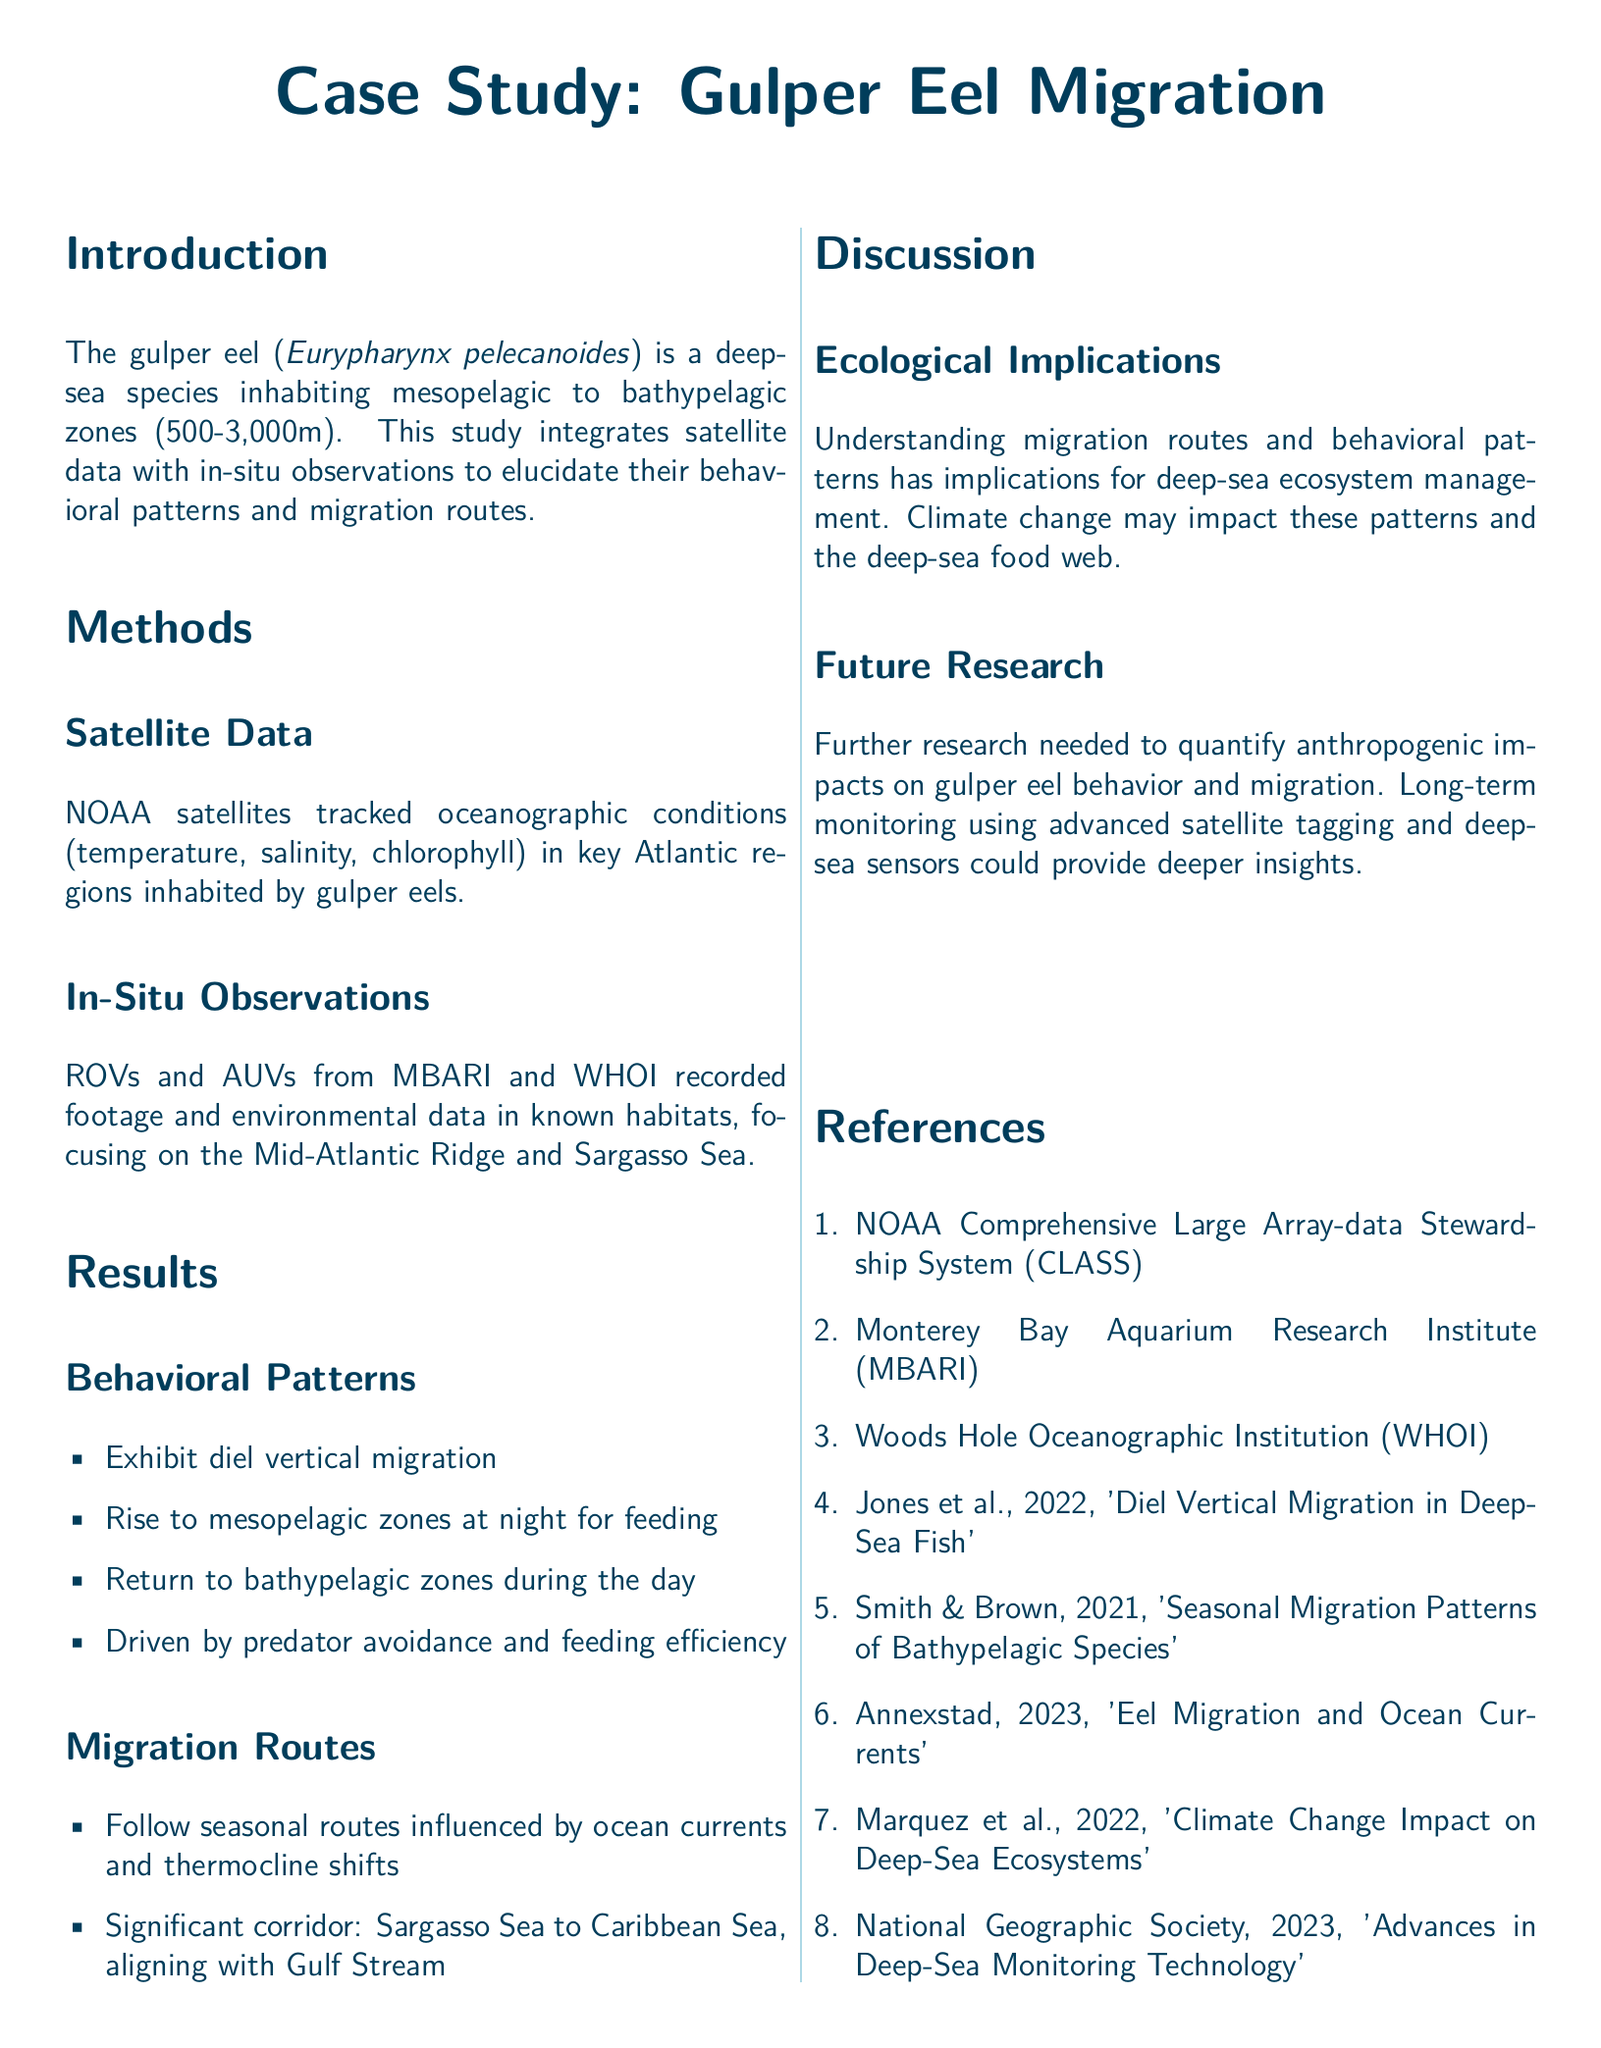What is the primary species discussed in the case study? The primary species discussed in the case study is the gulper eel, as indicated in the introduction.
Answer: gulper eel What oceanographic conditions were tracked using satellite data? The document mentions temperature, salinity, and chlorophyll as the tracked oceanographic conditions.
Answer: temperature, salinity, chlorophyll What is the depth range where gulper eels are found? The text states that gulper eels inhabit mesopelagic to bathypelagic zones, specifying the depth range.
Answer: 500-3000m Which two regions were key habitats observed in the study? The case study specifically highlights the Mid-Atlantic Ridge and Sargasso Sea as key habitats for gulper eels.
Answer: Mid-Atlantic Ridge and Sargasso Sea What behavioral pattern do gulper eels exhibit at night? The document notes that gulper eels rise to mesopelagic zones for feeding at night, indicating a specific behavioral pattern.
Answer: rise to mesopelagic zones for feeding What factors influence the migration routes of gulper eels? The migration routes of gulper eels are influenced by ocean currents and thermocline shifts, according to the results section.
Answer: ocean currents and thermocline shifts Which corridor do gulper eels significantly migrate through? The significant migration corridor mentioned is from the Sargasso Sea to the Caribbean Sea, aligning with the Gulf Stream.
Answer: Sargasso Sea to Caribbean Sea What type of research is suggested for the future? The document suggests that further research is needed to quantify anthropogenic impacts on gulper eel behavior and migration.
Answer: quantify anthropogenic impacts Which organizations were involved in the in-situ observations? The in-situ observations were conducted by organizations like MBARI and WHOI as referenced in the methods section.
Answer: MBARI and WHOI 